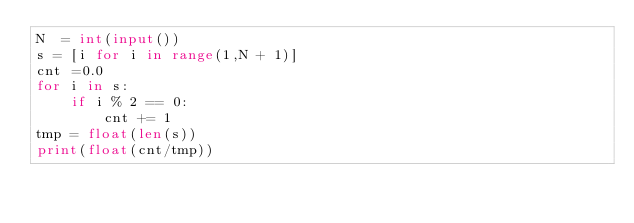Convert code to text. <code><loc_0><loc_0><loc_500><loc_500><_Python_>N  = int(input())
s = [i for i in range(1,N + 1)]
cnt =0.0
for i in s:
    if i % 2 == 0:
        cnt += 1
tmp = float(len(s))
print(float(cnt/tmp))


</code> 